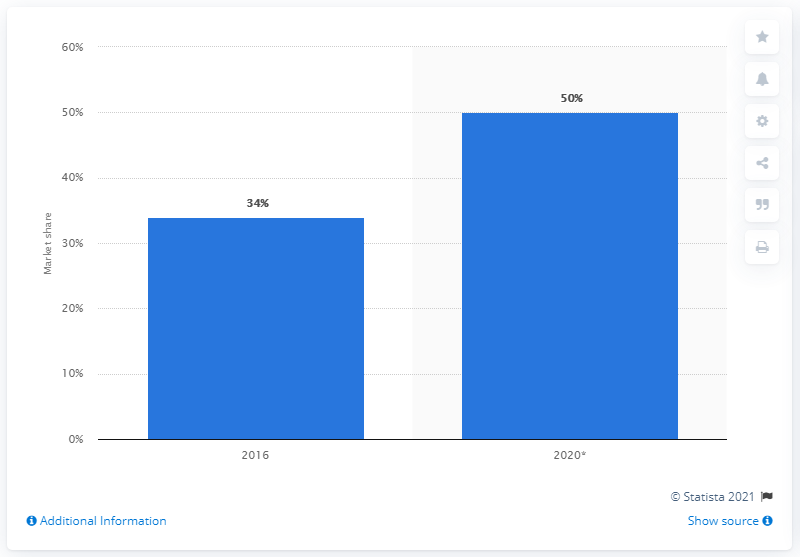Identify some key points in this picture. In 2016, Amazon accounted for approximately 34% of the total retail GMV (gross merchandise volume) in the United States. 